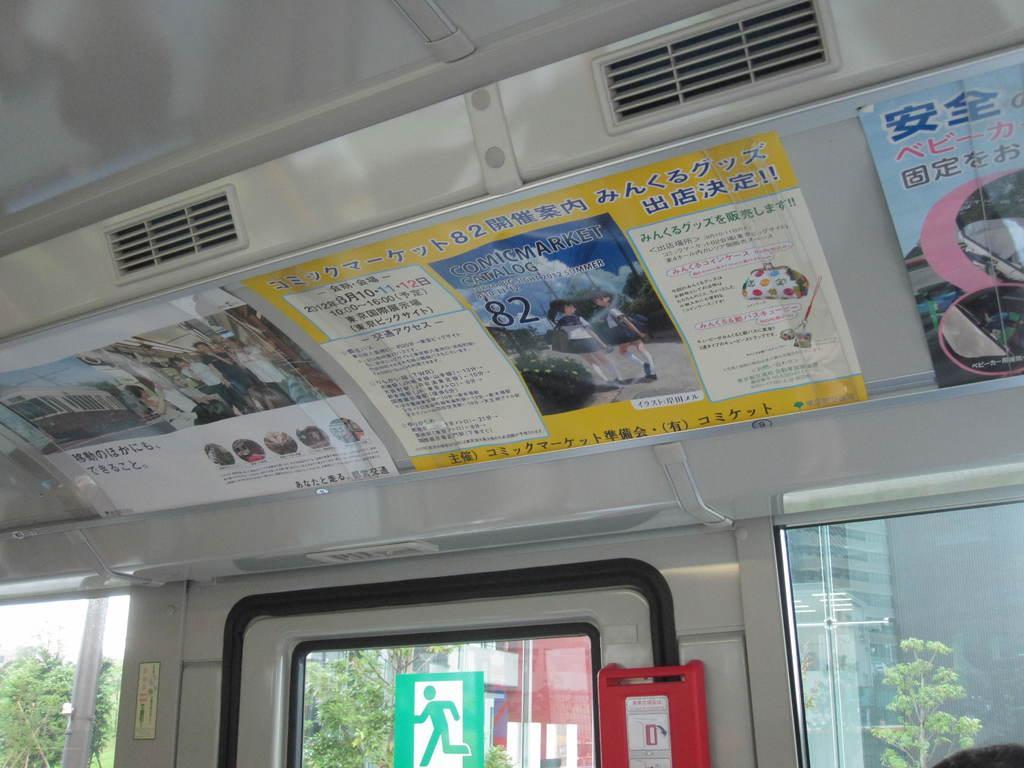Could you give a brief overview of what you see in this image? The picture is taken inside a vehicle. There are many posters. Through the glass window we can see outside there are trees, buildings, sign board and sky. 